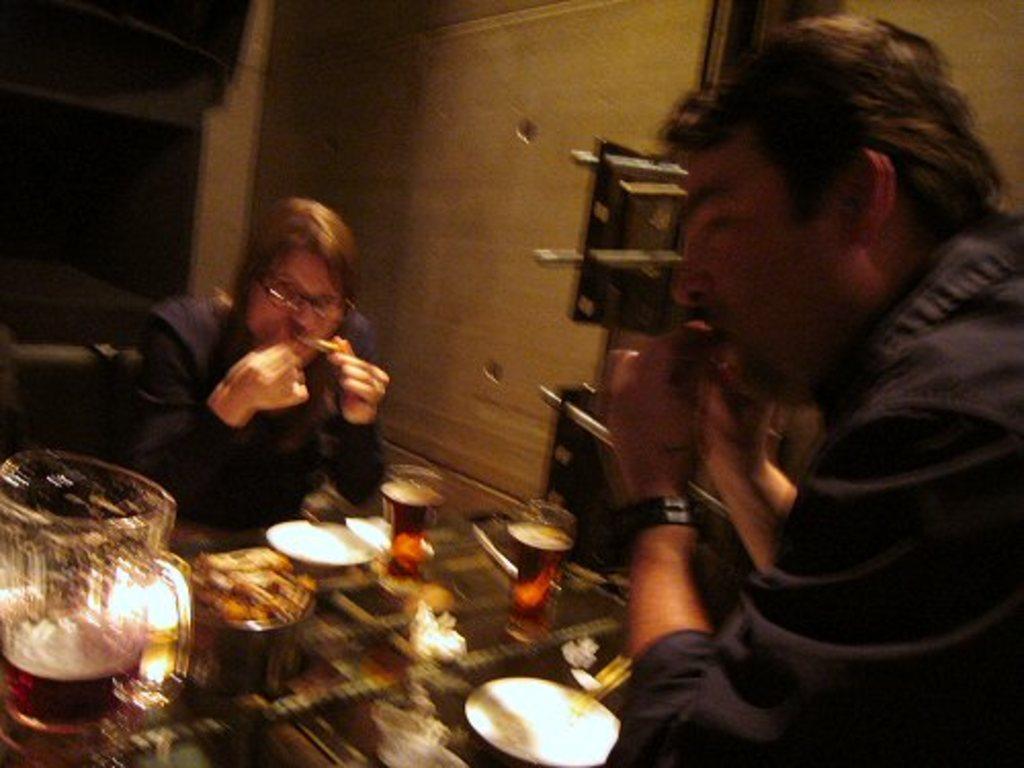Describe this image in one or two sentences. In the picture we can see a man and a woman sitting opposite to each other and in the middle of them, we can see a table on it, we can see a jar of alcohol and beside it, we can see some eatable items and some glasses of alcohol and behind them we can see a wall. 